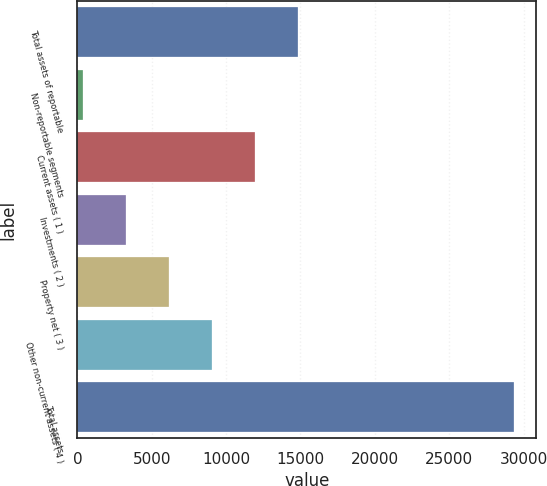<chart> <loc_0><loc_0><loc_500><loc_500><bar_chart><fcel>Total assets of reportable<fcel>Non-reportable segments<fcel>Current assets ( 1 )<fcel>Investments ( 2 )<fcel>Property net ( 3 )<fcel>Other non-current assets ( 4 )<fcel>Total assets<nl><fcel>14863<fcel>351<fcel>11960.6<fcel>3253.4<fcel>6155.8<fcel>9058.2<fcel>29375<nl></chart> 